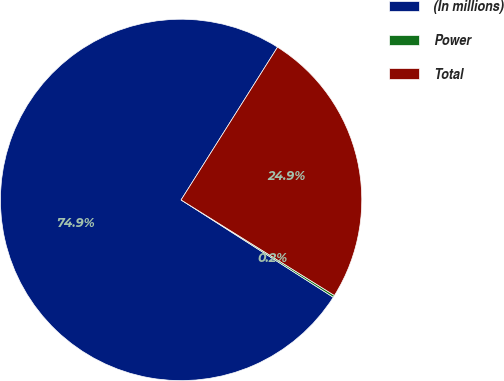<chart> <loc_0><loc_0><loc_500><loc_500><pie_chart><fcel>(In millions)<fcel>Power<fcel>Total<nl><fcel>74.91%<fcel>0.19%<fcel>24.91%<nl></chart> 